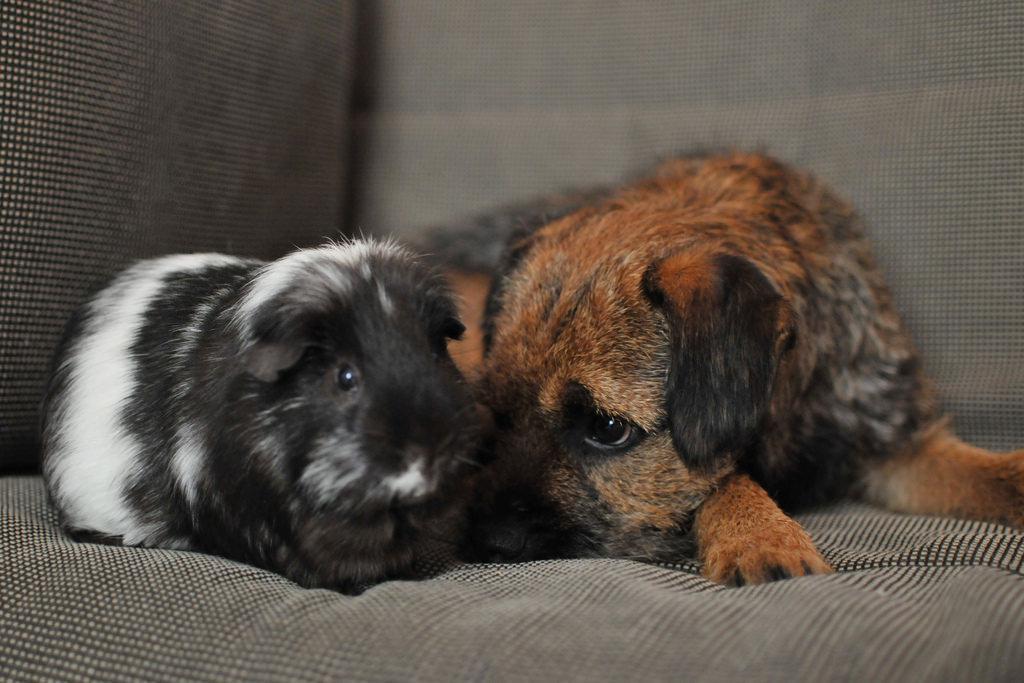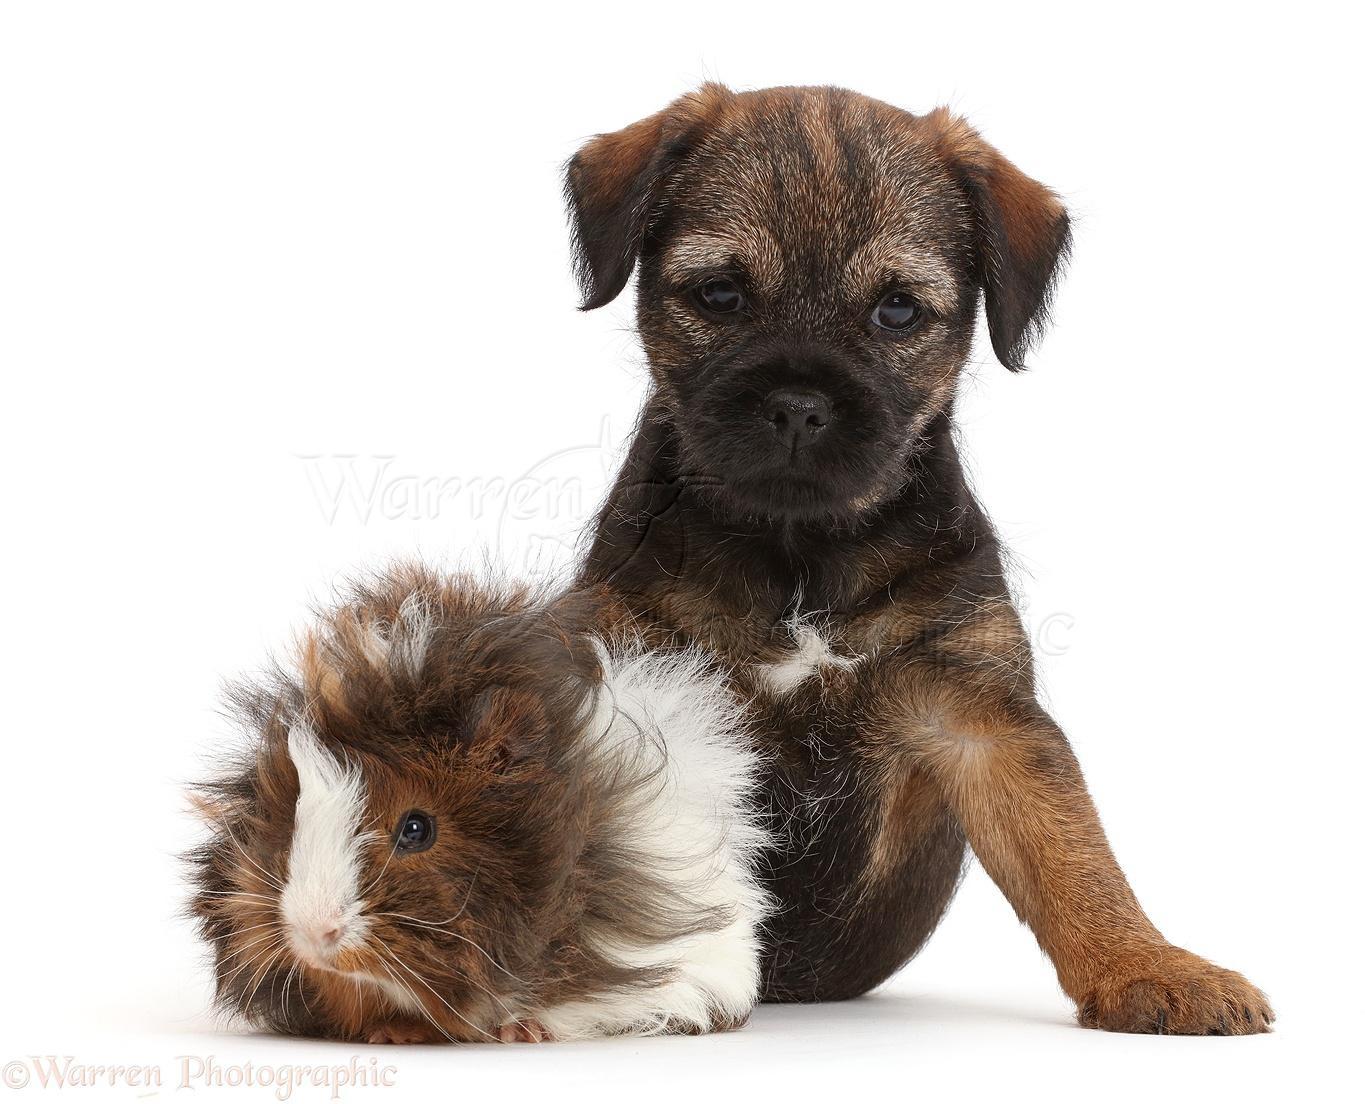The first image is the image on the left, the second image is the image on the right. Analyze the images presented: Is the assertion "Each image shows one guinea pig to the left of one puppy, and the right image shows a guinea pig overlapping a sitting puppy." valid? Answer yes or no. Yes. The first image is the image on the left, the second image is the image on the right. Evaluate the accuracy of this statement regarding the images: "There are exactly two dogs and two guinea pigs.". Is it true? Answer yes or no. Yes. 